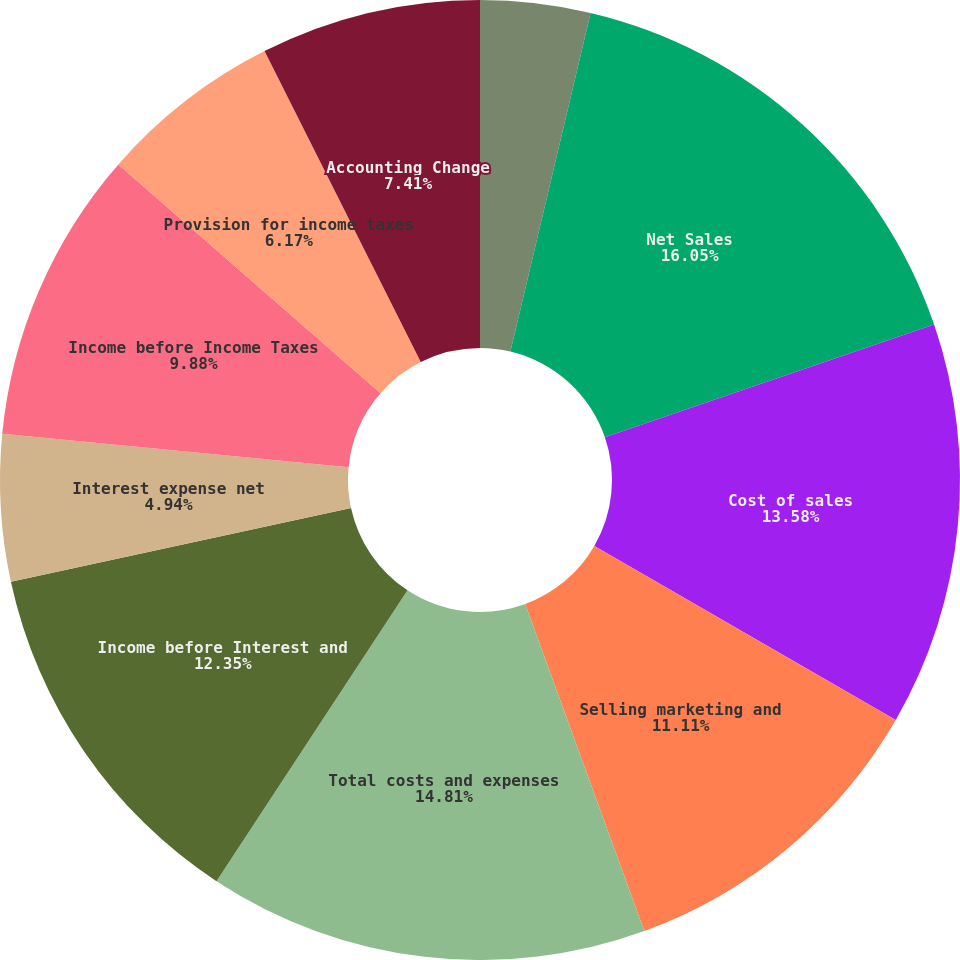<chart> <loc_0><loc_0><loc_500><loc_500><pie_chart><fcel>For the years ended December<fcel>Net Sales<fcel>Cost of sales<fcel>Selling marketing and<fcel>Total costs and expenses<fcel>Income before Interest and<fcel>Interest expense net<fcel>Income before Income Taxes<fcel>Provision for income taxes<fcel>Accounting Change<nl><fcel>3.7%<fcel>16.05%<fcel>13.58%<fcel>11.11%<fcel>14.81%<fcel>12.35%<fcel>4.94%<fcel>9.88%<fcel>6.17%<fcel>7.41%<nl></chart> 